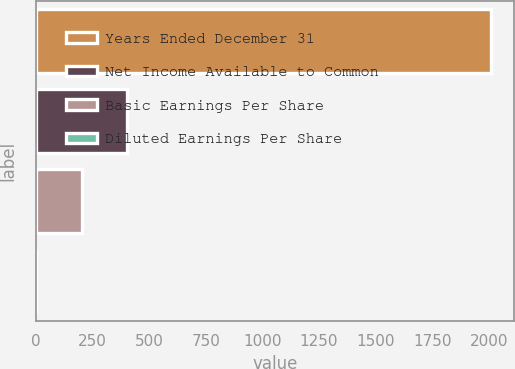<chart> <loc_0><loc_0><loc_500><loc_500><bar_chart><fcel>Years Ended December 31<fcel>Net Income Available to Common<fcel>Basic Earnings Per Share<fcel>Diluted Earnings Per Share<nl><fcel>2012<fcel>403.54<fcel>202.48<fcel>1.42<nl></chart> 